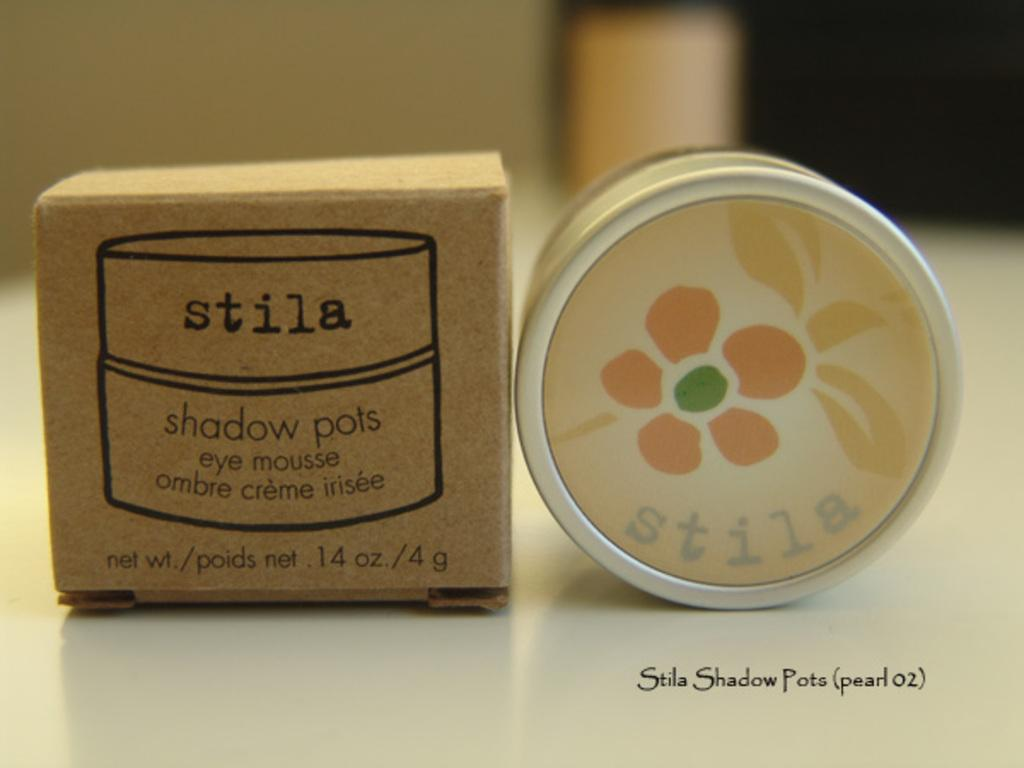<image>
Give a short and clear explanation of the subsequent image. Two packages of Stila makeup sit on a counter. 